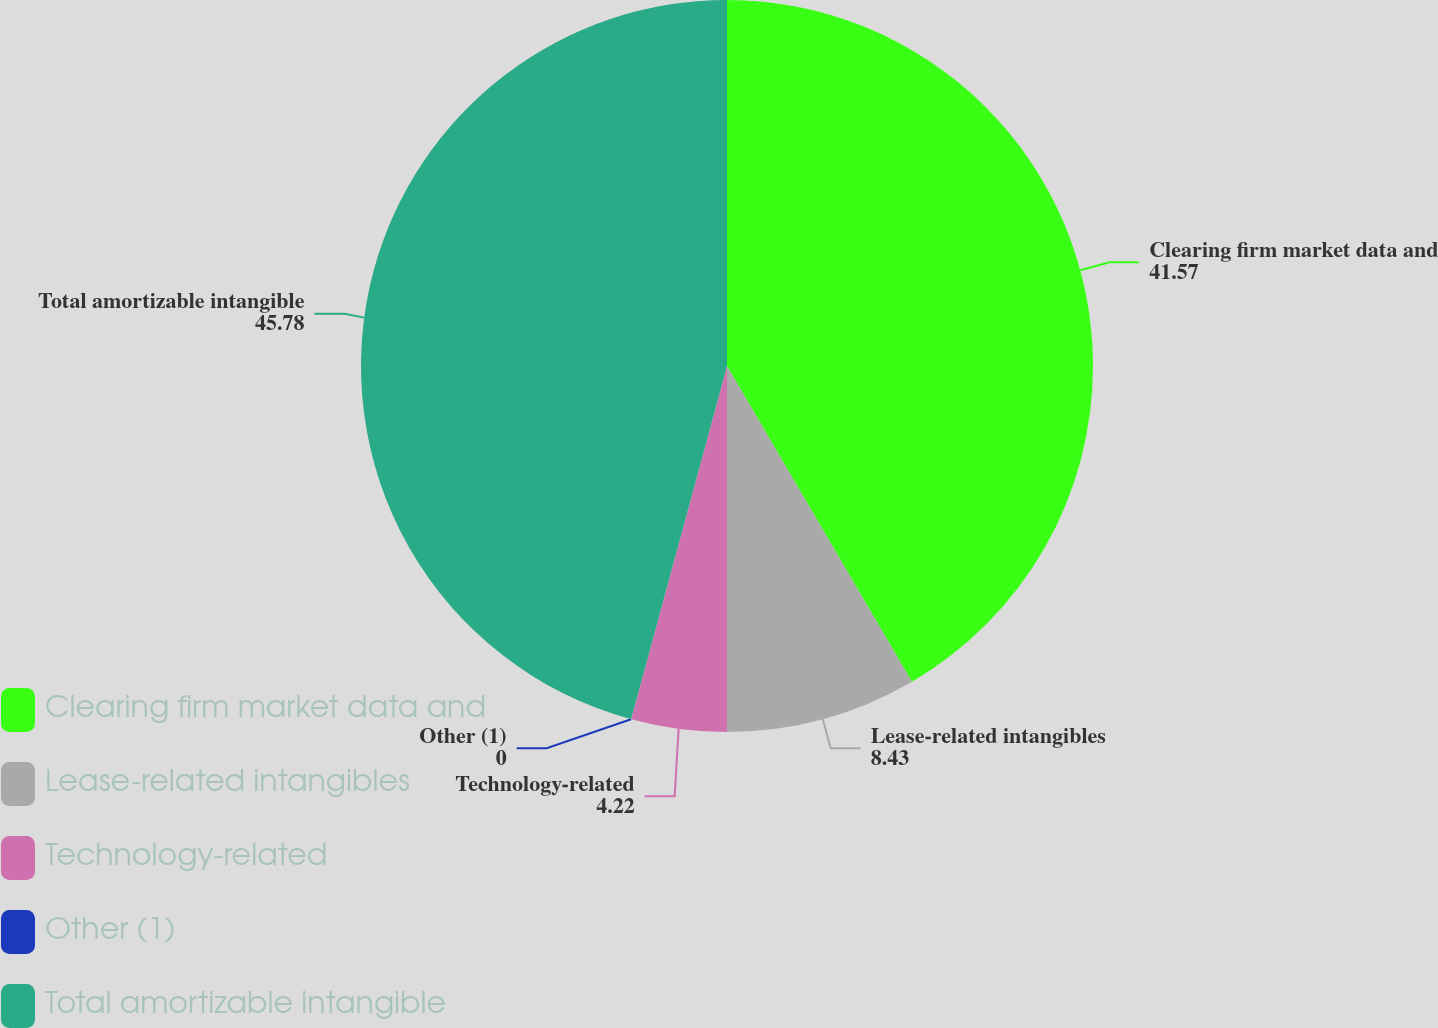Convert chart to OTSL. <chart><loc_0><loc_0><loc_500><loc_500><pie_chart><fcel>Clearing firm market data and<fcel>Lease-related intangibles<fcel>Technology-related<fcel>Other (1)<fcel>Total amortizable intangible<nl><fcel>41.57%<fcel>8.43%<fcel>4.22%<fcel>0.0%<fcel>45.78%<nl></chart> 